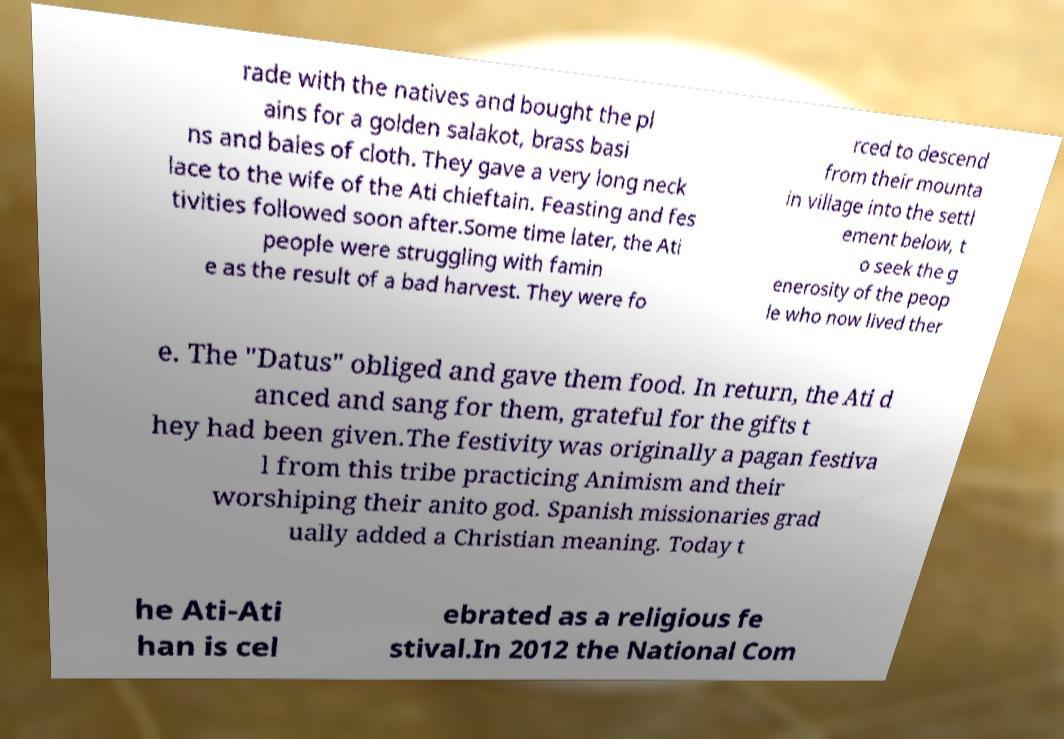I need the written content from this picture converted into text. Can you do that? rade with the natives and bought the pl ains for a golden salakot, brass basi ns and bales of cloth. They gave a very long neck lace to the wife of the Ati chieftain. Feasting and fes tivities followed soon after.Some time later, the Ati people were struggling with famin e as the result of a bad harvest. They were fo rced to descend from their mounta in village into the settl ement below, t o seek the g enerosity of the peop le who now lived ther e. The "Datus" obliged and gave them food. In return, the Ati d anced and sang for them, grateful for the gifts t hey had been given.The festivity was originally a pagan festiva l from this tribe practicing Animism and their worshiping their anito god. Spanish missionaries grad ually added a Christian meaning. Today t he Ati-Ati han is cel ebrated as a religious fe stival.In 2012 the National Com 